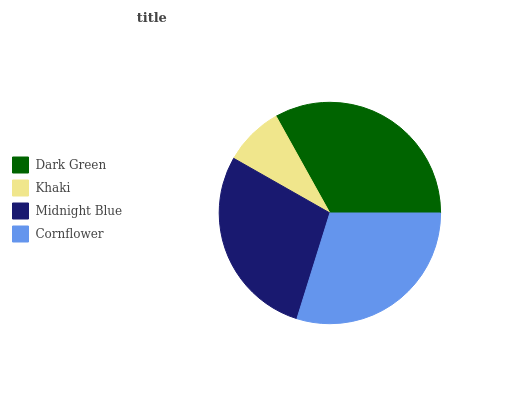Is Khaki the minimum?
Answer yes or no. Yes. Is Dark Green the maximum?
Answer yes or no. Yes. Is Midnight Blue the minimum?
Answer yes or no. No. Is Midnight Blue the maximum?
Answer yes or no. No. Is Midnight Blue greater than Khaki?
Answer yes or no. Yes. Is Khaki less than Midnight Blue?
Answer yes or no. Yes. Is Khaki greater than Midnight Blue?
Answer yes or no. No. Is Midnight Blue less than Khaki?
Answer yes or no. No. Is Cornflower the high median?
Answer yes or no. Yes. Is Midnight Blue the low median?
Answer yes or no. Yes. Is Khaki the high median?
Answer yes or no. No. Is Cornflower the low median?
Answer yes or no. No. 